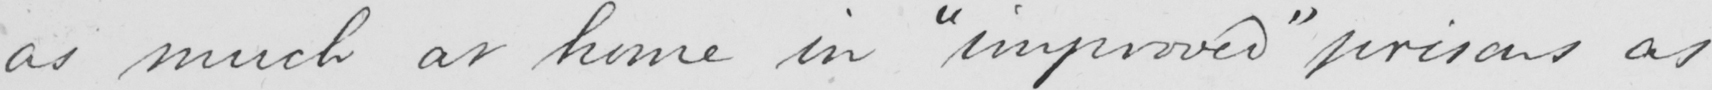Can you read and transcribe this handwriting? as much at home in  " improved "  prisons as 